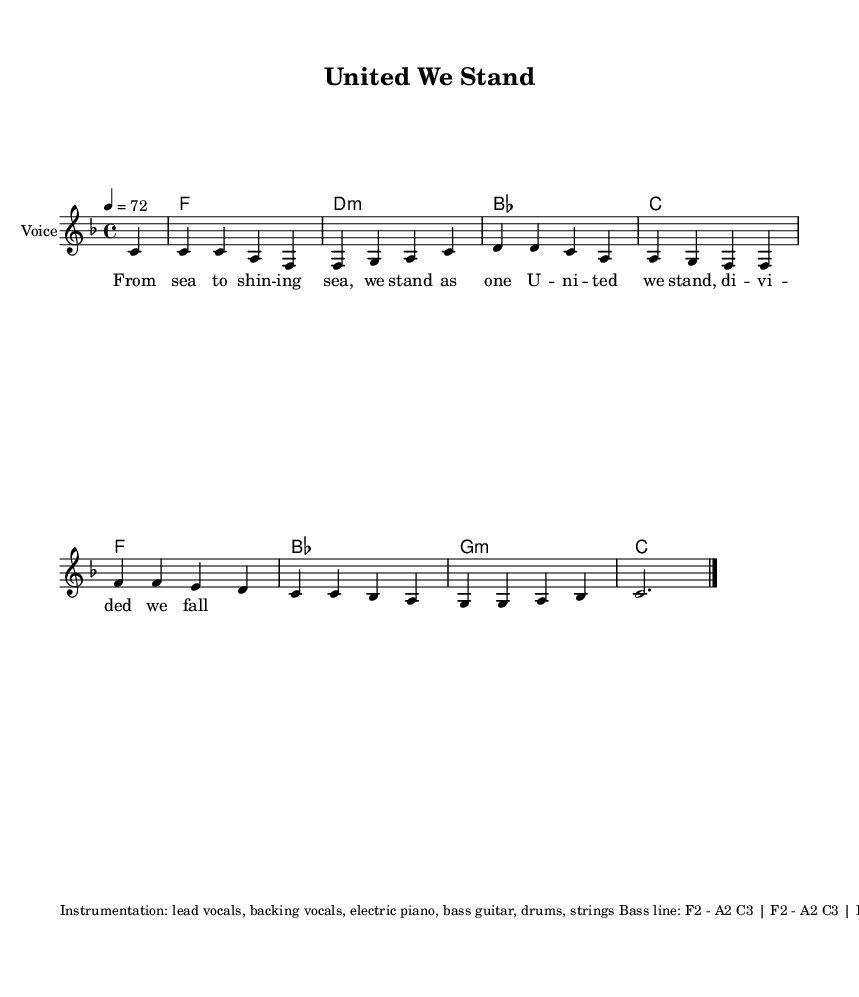What is the key signature of this music? The key signature is F major, which has one flat (B♭). This is determined by the presence of the flat symbol at the beginning of the staff.
Answer: F major What is the time signature of the piece? The time signature is 4/4, indicated at the beginning of the sheet music. This means there are four beats per measure, and the quarter note gets one beat.
Answer: 4/4 What is the tempo marking for the piece? The tempo marking is 72, indicated by the note '4 = 72'. This means that the quarter note should be played at a speed of 72 beats per minute.
Answer: 72 What is the chord progression of the first line of the harmonies? The chord progression in the first line is F, D minor, B flat, C. This can be deduced by looking at the chord symbols provided in the chord mode section.
Answer: F, D minor, B flat, C Which instrument primarily carries the melody? The melody is primarily carried by the voice, as indicated in the score under the staff that states "Voice".
Answer: Voice What rhythm pattern does the drum section follow? The drum pattern follows a four-on-the-floor beat, where the kick drum plays on beats 1 and 3, while the snare plays on beats 2 and 4, accompanied by hi-hat eighth notes throughout. This is typical in disco music, supporting its danceable quality.
Answer: Four-on-the-floor How many lines of lyrics are there in the melody? There are two lines of lyrics in the melody as seen in the lyric mode, indicating a clear division of text corresponding to the melodic phrasing.
Answer: 2 